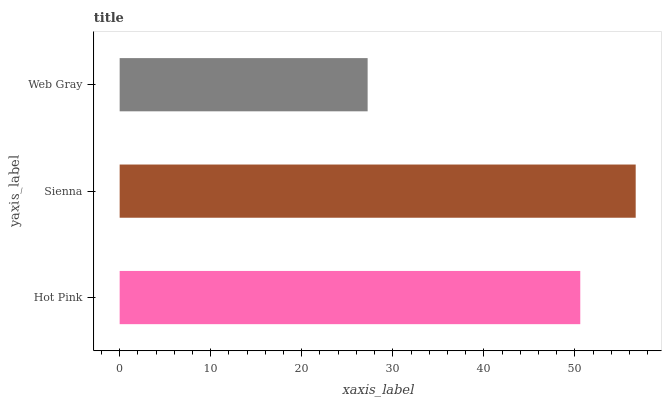Is Web Gray the minimum?
Answer yes or no. Yes. Is Sienna the maximum?
Answer yes or no. Yes. Is Sienna the minimum?
Answer yes or no. No. Is Web Gray the maximum?
Answer yes or no. No. Is Sienna greater than Web Gray?
Answer yes or no. Yes. Is Web Gray less than Sienna?
Answer yes or no. Yes. Is Web Gray greater than Sienna?
Answer yes or no. No. Is Sienna less than Web Gray?
Answer yes or no. No. Is Hot Pink the high median?
Answer yes or no. Yes. Is Hot Pink the low median?
Answer yes or no. Yes. Is Sienna the high median?
Answer yes or no. No. Is Web Gray the low median?
Answer yes or no. No. 